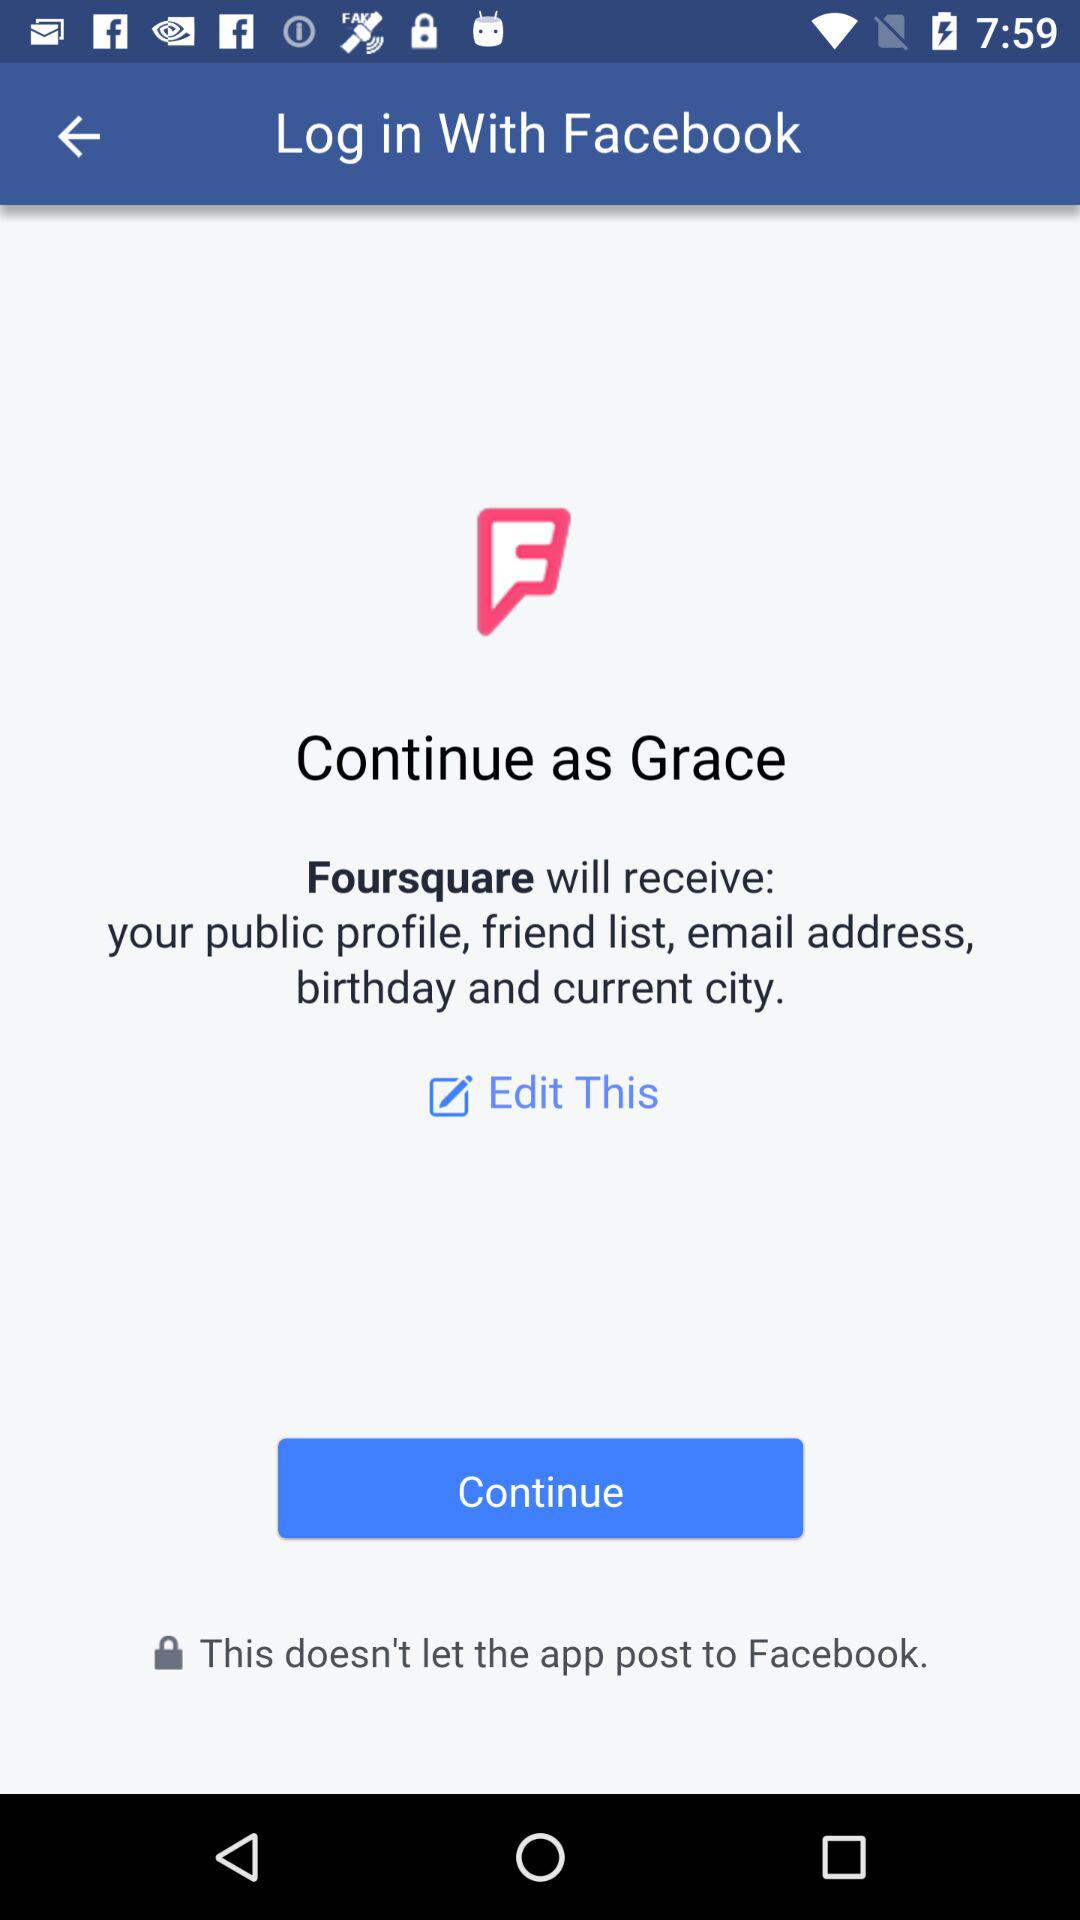What is the name of the user? The name of the user is Grace. 